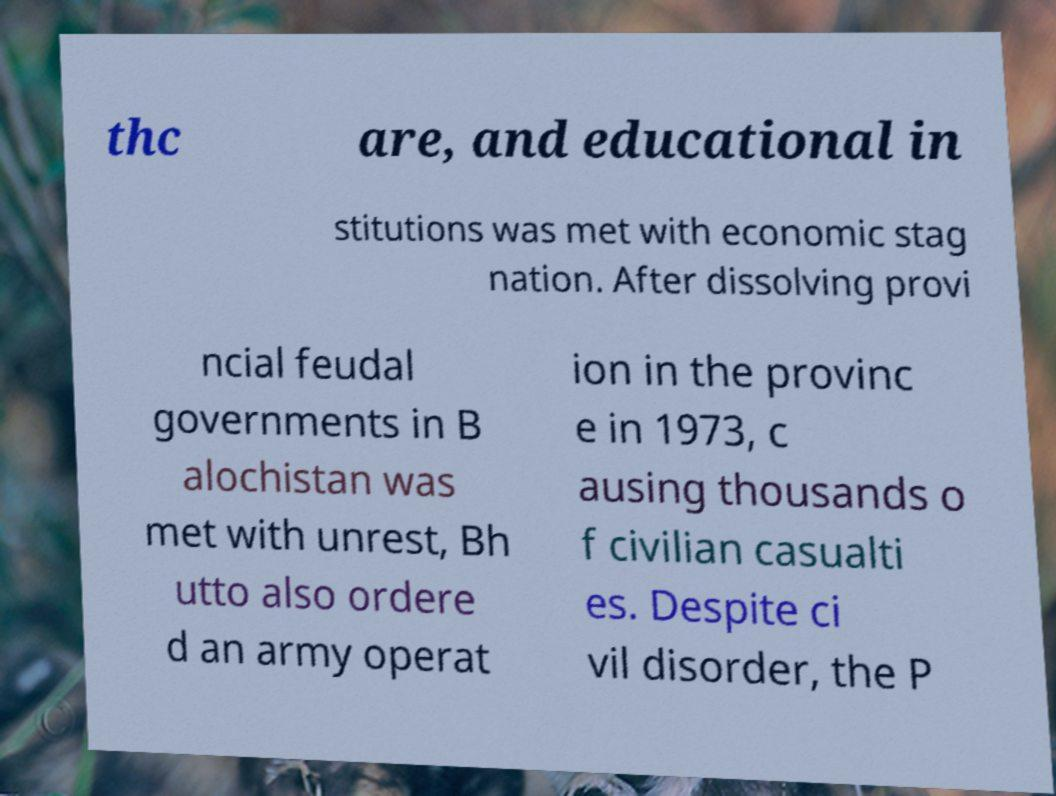For documentation purposes, I need the text within this image transcribed. Could you provide that? thc are, and educational in stitutions was met with economic stag nation. After dissolving provi ncial feudal governments in B alochistan was met with unrest, Bh utto also ordere d an army operat ion in the provinc e in 1973, c ausing thousands o f civilian casualti es. Despite ci vil disorder, the P 